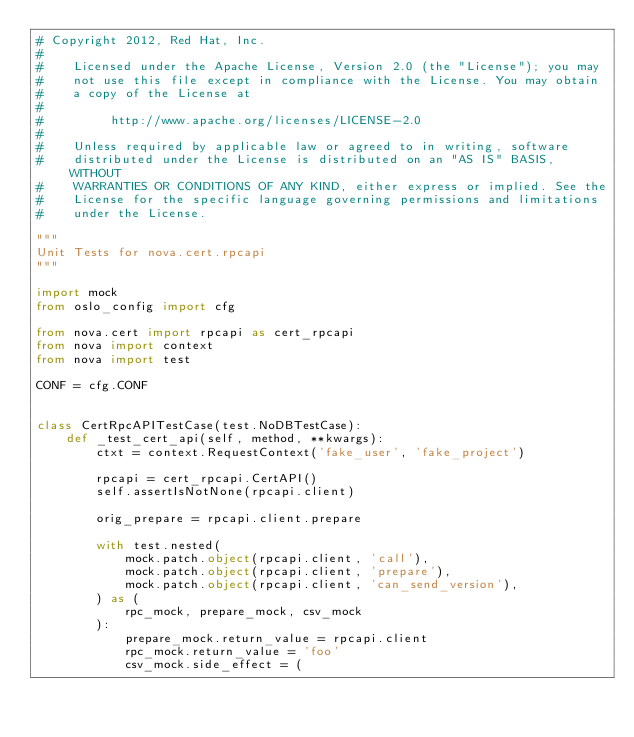<code> <loc_0><loc_0><loc_500><loc_500><_Python_># Copyright 2012, Red Hat, Inc.
#
#    Licensed under the Apache License, Version 2.0 (the "License"); you may
#    not use this file except in compliance with the License. You may obtain
#    a copy of the License at
#
#         http://www.apache.org/licenses/LICENSE-2.0
#
#    Unless required by applicable law or agreed to in writing, software
#    distributed under the License is distributed on an "AS IS" BASIS, WITHOUT
#    WARRANTIES OR CONDITIONS OF ANY KIND, either express or implied. See the
#    License for the specific language governing permissions and limitations
#    under the License.

"""
Unit Tests for nova.cert.rpcapi
"""

import mock
from oslo_config import cfg

from nova.cert import rpcapi as cert_rpcapi
from nova import context
from nova import test

CONF = cfg.CONF


class CertRpcAPITestCase(test.NoDBTestCase):
    def _test_cert_api(self, method, **kwargs):
        ctxt = context.RequestContext('fake_user', 'fake_project')

        rpcapi = cert_rpcapi.CertAPI()
        self.assertIsNotNone(rpcapi.client)

        orig_prepare = rpcapi.client.prepare

        with test.nested(
            mock.patch.object(rpcapi.client, 'call'),
            mock.patch.object(rpcapi.client, 'prepare'),
            mock.patch.object(rpcapi.client, 'can_send_version'),
        ) as (
            rpc_mock, prepare_mock, csv_mock
        ):
            prepare_mock.return_value = rpcapi.client
            rpc_mock.return_value = 'foo'
            csv_mock.side_effect = (</code> 